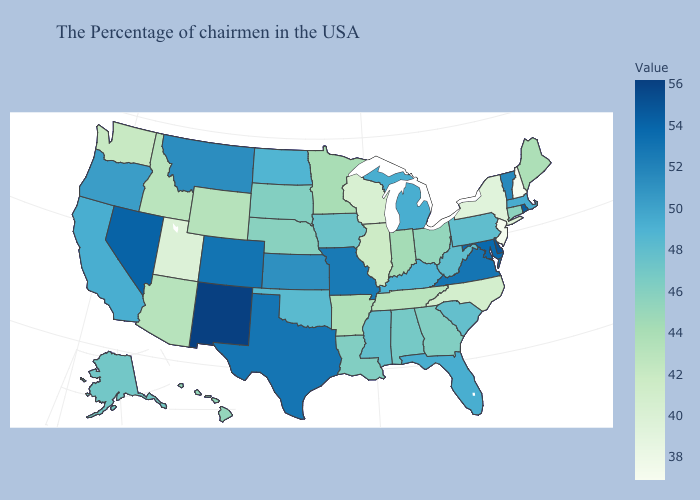Does Utah have the lowest value in the West?
Concise answer only. Yes. Does the map have missing data?
Answer briefly. No. Does South Carolina have a lower value than Texas?
Be succinct. Yes. Which states have the lowest value in the West?
Give a very brief answer. Utah. Is the legend a continuous bar?
Write a very short answer. Yes. Which states have the lowest value in the South?
Concise answer only. North Carolina. 